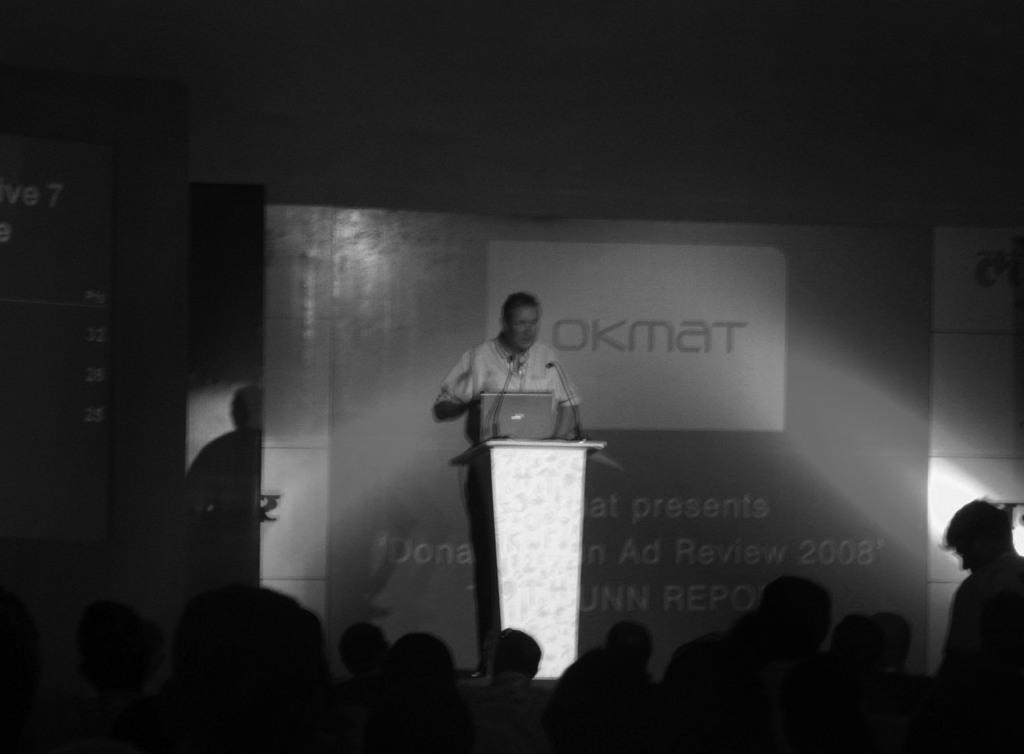Please provide a concise description of this image. In this image I can see the black and white picture in which I can see number of persons. I can see the stage, a person standing on the stage behind the podium. On the podium I can see a laptop and two microphones. In the background I can see the banner, a screen and the dark background. 